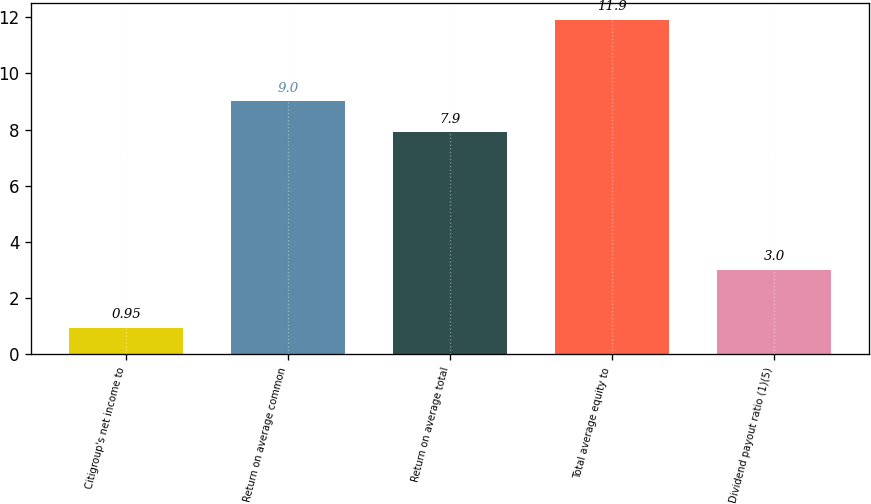Convert chart to OTSL. <chart><loc_0><loc_0><loc_500><loc_500><bar_chart><fcel>Citigroup's net income to<fcel>Return on average common<fcel>Return on average total<fcel>Total average equity to<fcel>Dividend payout ratio (1)(5)<nl><fcel>0.95<fcel>9<fcel>7.9<fcel>11.9<fcel>3<nl></chart> 